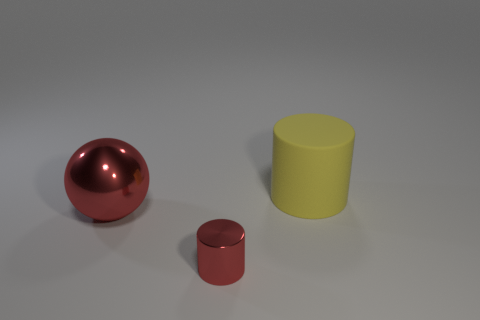How does the lighting in the scene affect the appearance of the objects? The soft, diffuse lighting in the scene casts gentle shadows and highlights the objects’ surfaces. There's a subtle contrast that accentuates the metallic sheen of the red objects and the matte finish of the yellow one.  What could be the possible sizes of these objects? Without a common reference for scale, it's challenging to determine the exact sizes. However, based on the proportions relative to each other, they might be small enough to fit on a tabletop. 